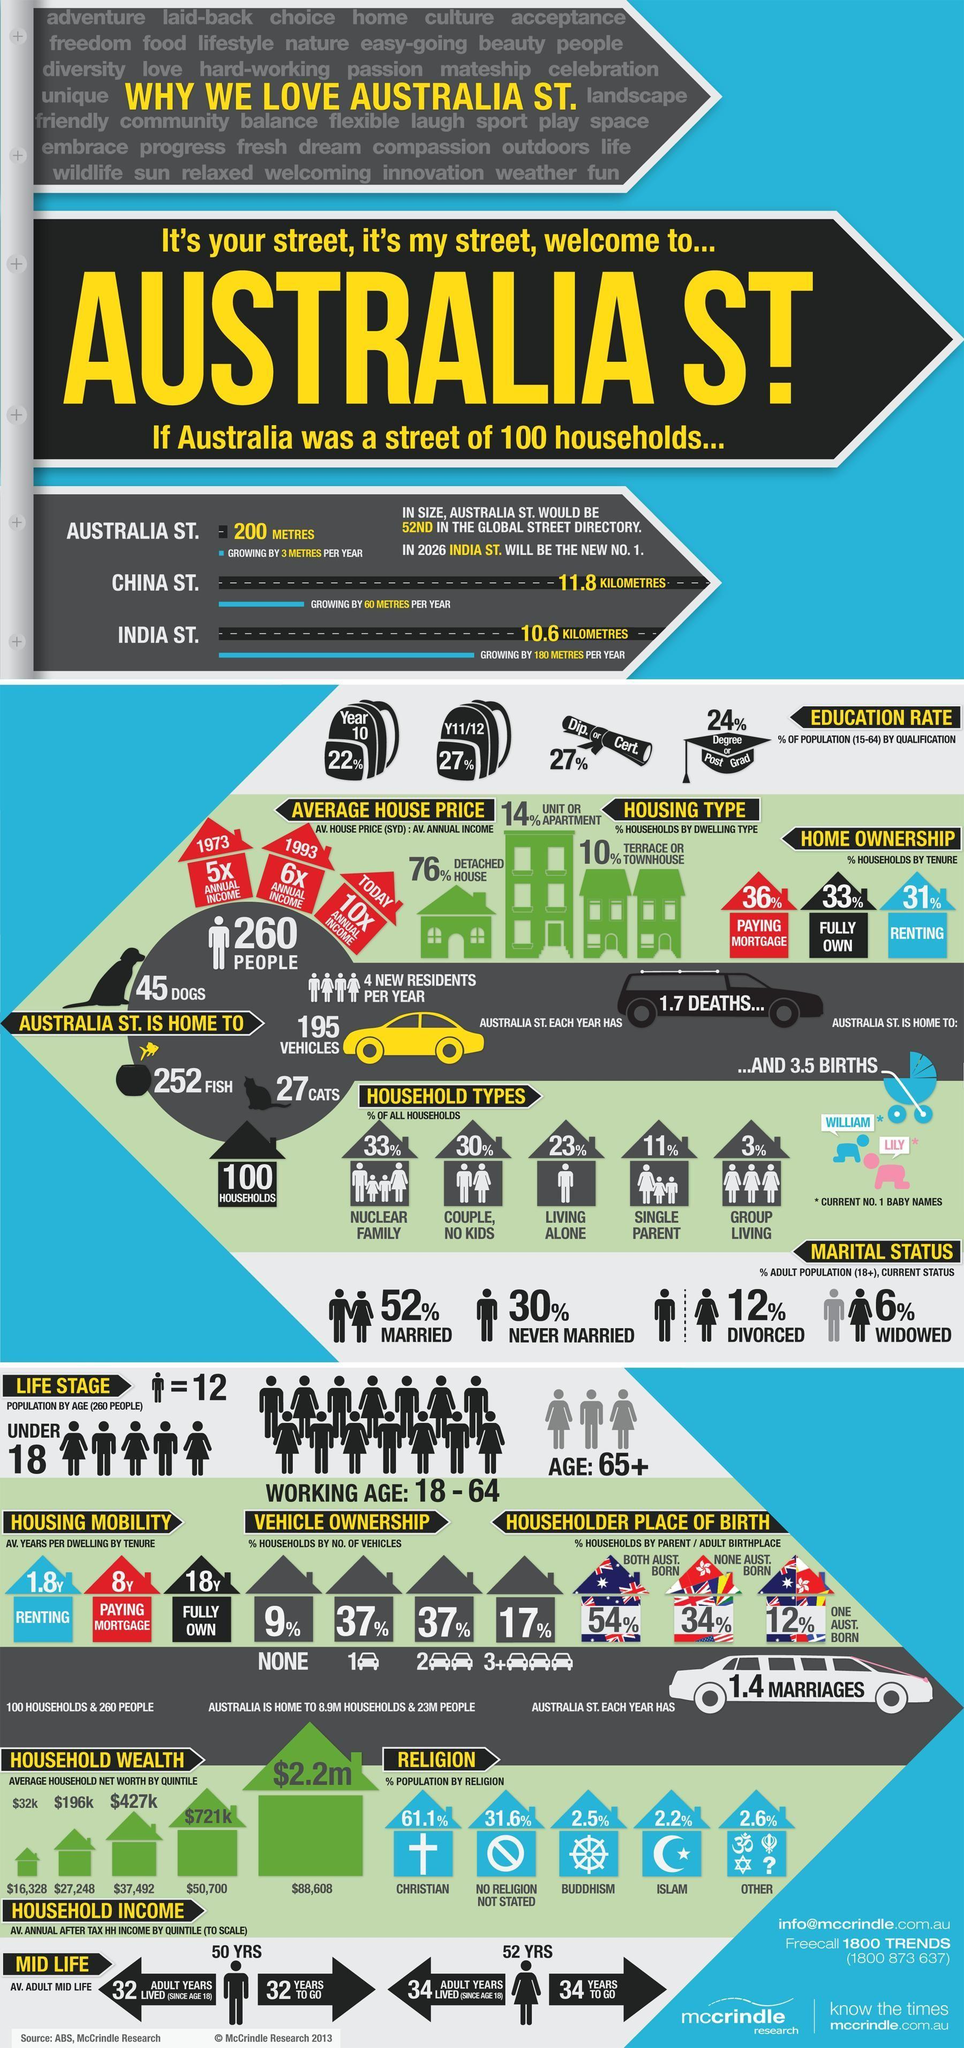People of which religious faith is predominant?
Answer the question with a short phrase. CHRISTIAN Which male baby name is popular in Australia? WILLIAM What percent of adult population are divorced and widowed? 18% Which type of household is most common in Australia? NUCLEAR FAMILY Which is the fastest growing street? INDIA ST. What percent of population has a Diploma or Certificate? 27% What percentage of households have 2 vehicles? 37% 